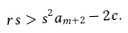Convert formula to latex. <formula><loc_0><loc_0><loc_500><loc_500>r s > s ^ { 2 } a _ { m + 2 } - 2 c .</formula> 